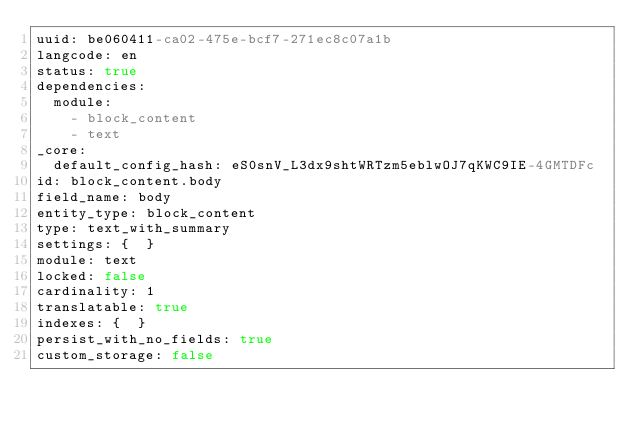<code> <loc_0><loc_0><loc_500><loc_500><_YAML_>uuid: be060411-ca02-475e-bcf7-271ec8c07a1b
langcode: en
status: true
dependencies:
  module:
    - block_content
    - text
_core:
  default_config_hash: eS0snV_L3dx9shtWRTzm5eblwOJ7qKWC9IE-4GMTDFc
id: block_content.body
field_name: body
entity_type: block_content
type: text_with_summary
settings: {  }
module: text
locked: false
cardinality: 1
translatable: true
indexes: {  }
persist_with_no_fields: true
custom_storage: false
</code> 